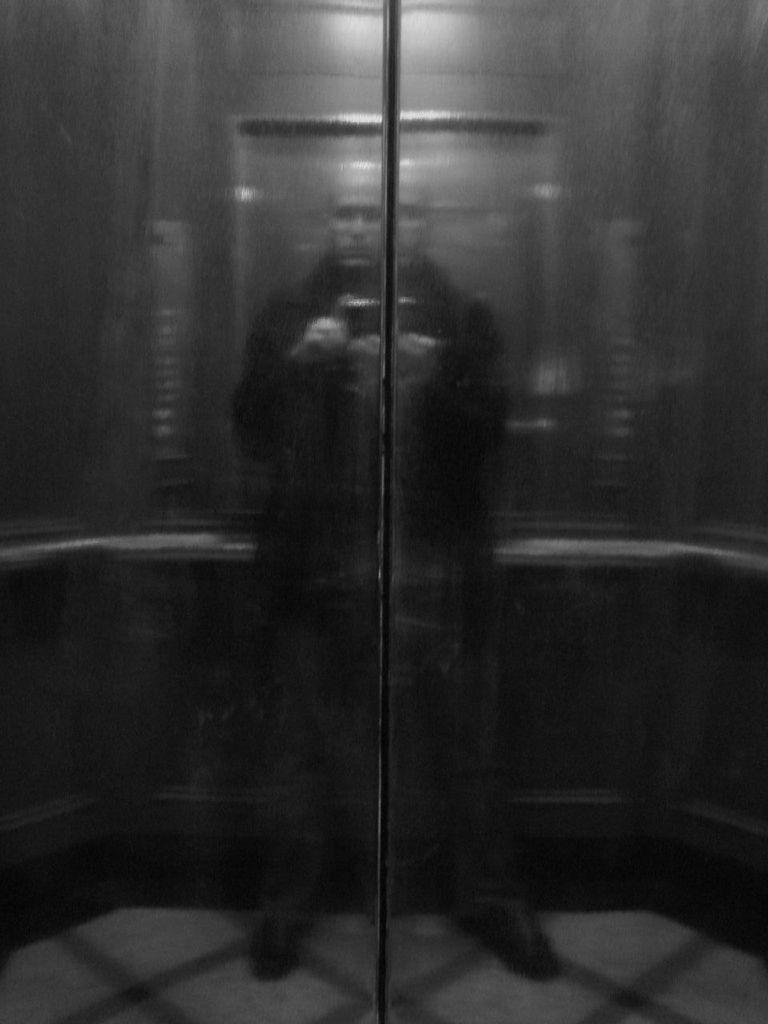What can be seen in the image through a reflection? There is a man in the image, visible through a reflection. What type of news is being reported by the plantation in the image? There is no plantation or news reporting present in the image; it only features a man visible through a reflection. 